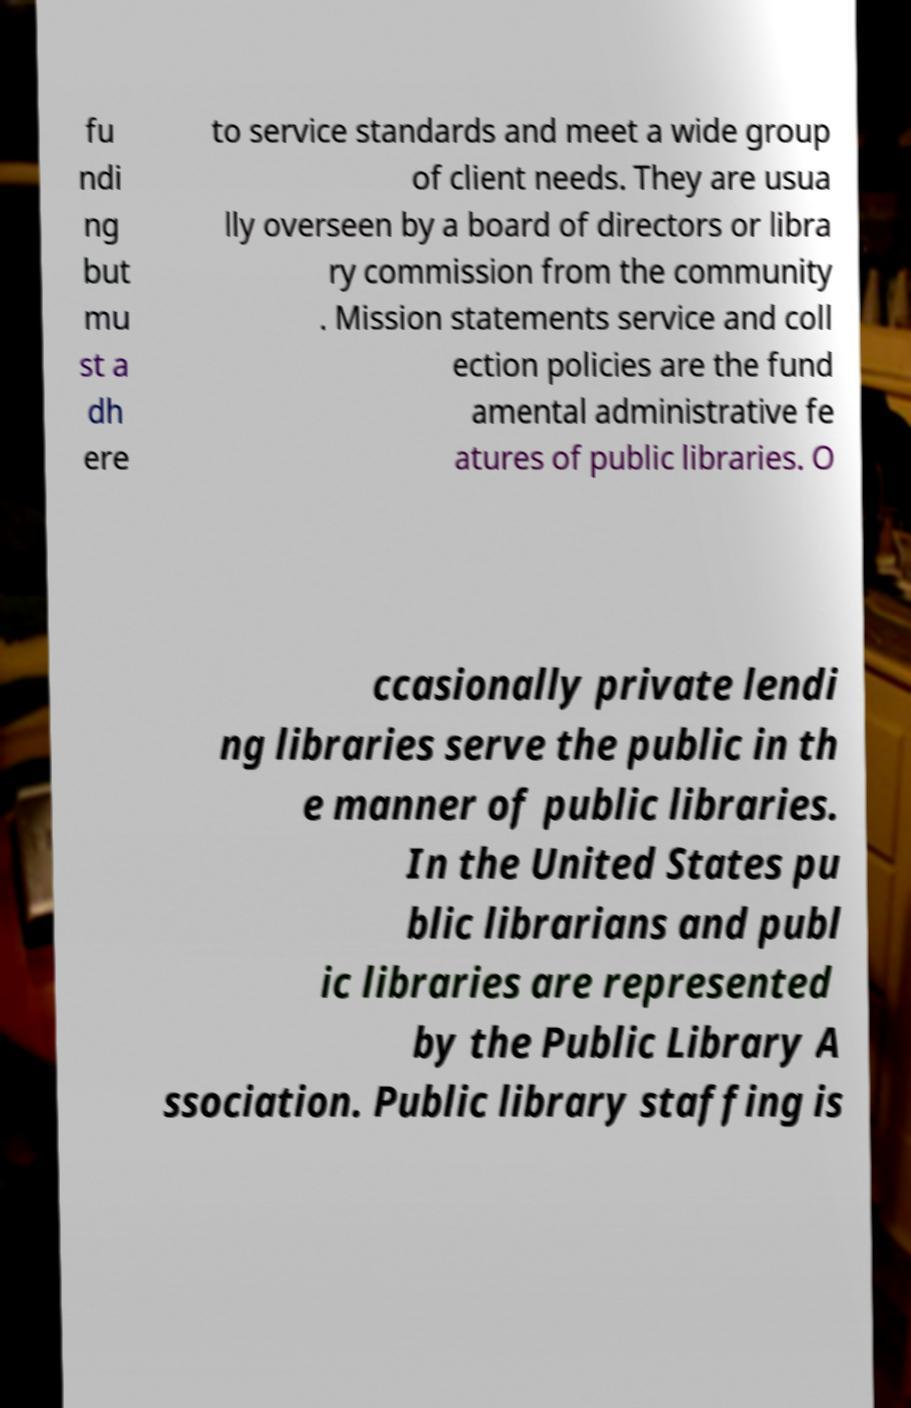What messages or text are displayed in this image? I need them in a readable, typed format. fu ndi ng but mu st a dh ere to service standards and meet a wide group of client needs. They are usua lly overseen by a board of directors or libra ry commission from the community . Mission statements service and coll ection policies are the fund amental administrative fe atures of public libraries. O ccasionally private lendi ng libraries serve the public in th e manner of public libraries. In the United States pu blic librarians and publ ic libraries are represented by the Public Library A ssociation. Public library staffing is 